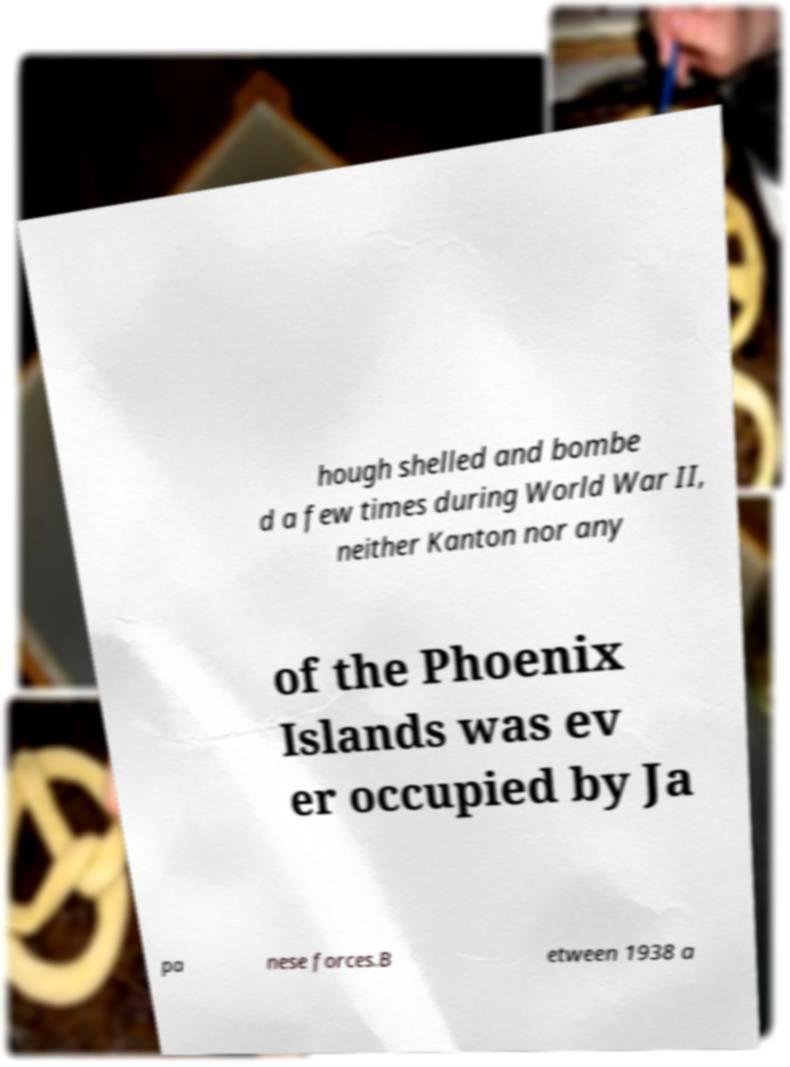Can you accurately transcribe the text from the provided image for me? hough shelled and bombe d a few times during World War II, neither Kanton nor any of the Phoenix Islands was ev er occupied by Ja pa nese forces.B etween 1938 a 